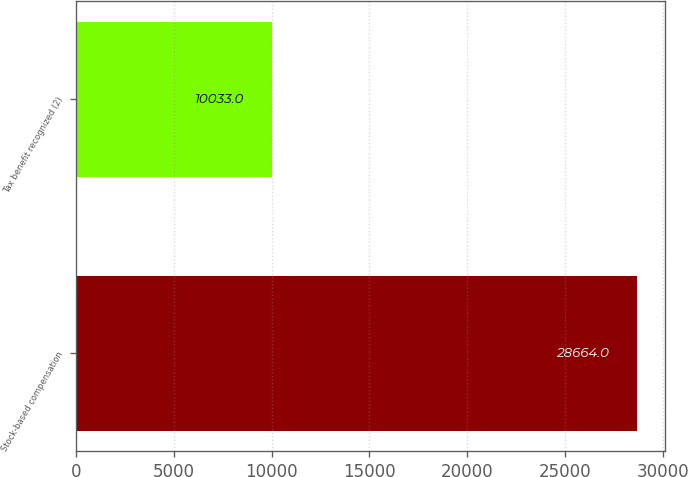Convert chart to OTSL. <chart><loc_0><loc_0><loc_500><loc_500><bar_chart><fcel>Stock-based compensation<fcel>Tax benefit recognized (2)<nl><fcel>28664<fcel>10033<nl></chart> 